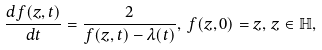Convert formula to latex. <formula><loc_0><loc_0><loc_500><loc_500>\frac { d f ( z , t ) } { d t } = \frac { 2 } { f ( z , t ) - \lambda ( t ) } , \, f ( z , 0 ) = z , \, z \in \mathbb { H } ,</formula> 